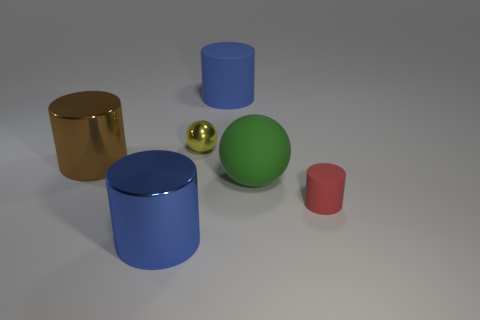Subtract 2 cylinders. How many cylinders are left? 2 Subtract all brown cylinders. How many cylinders are left? 3 Subtract all purple cylinders. Subtract all purple spheres. How many cylinders are left? 4 Add 3 purple things. How many objects exist? 9 Subtract all cylinders. How many objects are left? 2 Subtract 0 cyan cubes. How many objects are left? 6 Subtract all tiny metal spheres. Subtract all big red cylinders. How many objects are left? 5 Add 5 large blue shiny cylinders. How many large blue shiny cylinders are left? 6 Add 5 green things. How many green things exist? 6 